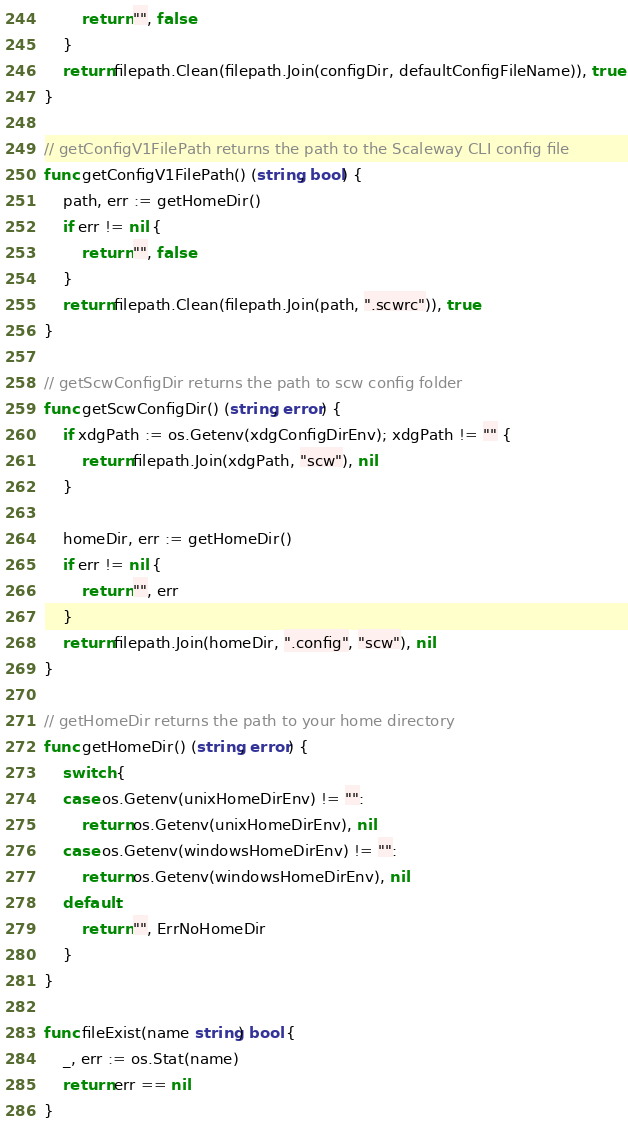<code> <loc_0><loc_0><loc_500><loc_500><_Go_>		return "", false
	}
	return filepath.Clean(filepath.Join(configDir, defaultConfigFileName)), true
}

// getConfigV1FilePath returns the path to the Scaleway CLI config file
func getConfigV1FilePath() (string, bool) {
	path, err := getHomeDir()
	if err != nil {
		return "", false
	}
	return filepath.Clean(filepath.Join(path, ".scwrc")), true
}

// getScwConfigDir returns the path to scw config folder
func getScwConfigDir() (string, error) {
	if xdgPath := os.Getenv(xdgConfigDirEnv); xdgPath != "" {
		return filepath.Join(xdgPath, "scw"), nil
	}

	homeDir, err := getHomeDir()
	if err != nil {
		return "", err
	}
	return filepath.Join(homeDir, ".config", "scw"), nil
}

// getHomeDir returns the path to your home directory
func getHomeDir() (string, error) {
	switch {
	case os.Getenv(unixHomeDirEnv) != "":
		return os.Getenv(unixHomeDirEnv), nil
	case os.Getenv(windowsHomeDirEnv) != "":
		return os.Getenv(windowsHomeDirEnv), nil
	default:
		return "", ErrNoHomeDir
	}
}

func fileExist(name string) bool {
	_, err := os.Stat(name)
	return err == nil
}
</code> 